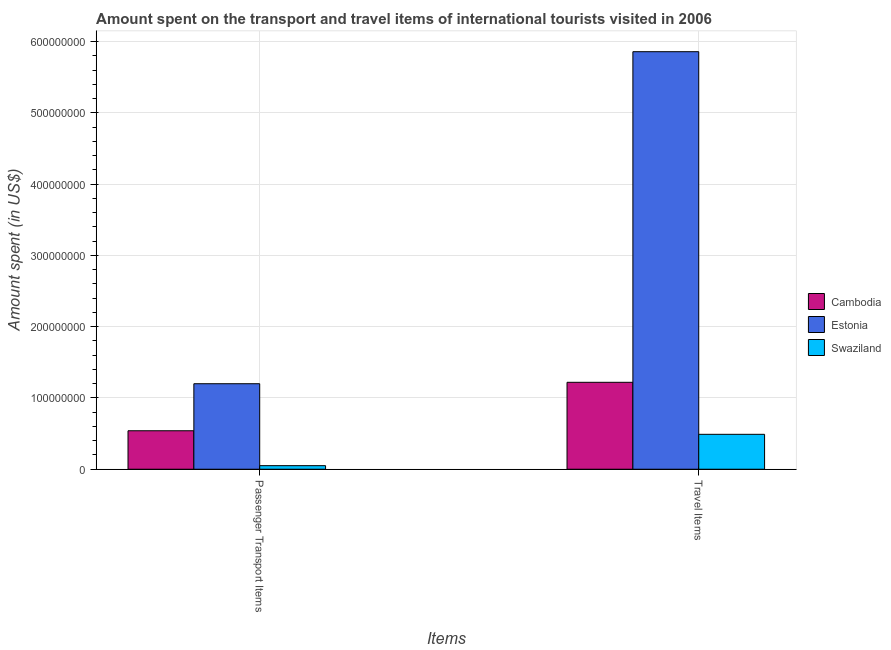Are the number of bars per tick equal to the number of legend labels?
Ensure brevity in your answer.  Yes. How many bars are there on the 2nd tick from the left?
Make the answer very short. 3. What is the label of the 1st group of bars from the left?
Your answer should be compact. Passenger Transport Items. What is the amount spent on passenger transport items in Estonia?
Keep it short and to the point. 1.20e+08. Across all countries, what is the maximum amount spent on passenger transport items?
Make the answer very short. 1.20e+08. Across all countries, what is the minimum amount spent in travel items?
Keep it short and to the point. 4.90e+07. In which country was the amount spent on passenger transport items maximum?
Your answer should be compact. Estonia. In which country was the amount spent on passenger transport items minimum?
Ensure brevity in your answer.  Swaziland. What is the total amount spent in travel items in the graph?
Your answer should be compact. 7.57e+08. What is the difference between the amount spent on passenger transport items in Estonia and that in Swaziland?
Make the answer very short. 1.15e+08. What is the difference between the amount spent in travel items in Swaziland and the amount spent on passenger transport items in Cambodia?
Your answer should be compact. -5.00e+06. What is the average amount spent in travel items per country?
Provide a short and direct response. 2.52e+08. What is the difference between the amount spent on passenger transport items and amount spent in travel items in Swaziland?
Provide a succinct answer. -4.40e+07. In how many countries, is the amount spent on passenger transport items greater than 380000000 US$?
Provide a succinct answer. 0. What is the ratio of the amount spent on passenger transport items in Swaziland to that in Cambodia?
Provide a succinct answer. 0.09. What does the 1st bar from the left in Passenger Transport Items represents?
Offer a very short reply. Cambodia. What does the 1st bar from the right in Travel Items represents?
Ensure brevity in your answer.  Swaziland. Does the graph contain grids?
Keep it short and to the point. Yes. How are the legend labels stacked?
Give a very brief answer. Vertical. What is the title of the graph?
Ensure brevity in your answer.  Amount spent on the transport and travel items of international tourists visited in 2006. Does "Botswana" appear as one of the legend labels in the graph?
Offer a very short reply. No. What is the label or title of the X-axis?
Give a very brief answer. Items. What is the label or title of the Y-axis?
Ensure brevity in your answer.  Amount spent (in US$). What is the Amount spent (in US$) of Cambodia in Passenger Transport Items?
Give a very brief answer. 5.40e+07. What is the Amount spent (in US$) in Estonia in Passenger Transport Items?
Provide a short and direct response. 1.20e+08. What is the Amount spent (in US$) of Swaziland in Passenger Transport Items?
Give a very brief answer. 5.00e+06. What is the Amount spent (in US$) in Cambodia in Travel Items?
Keep it short and to the point. 1.22e+08. What is the Amount spent (in US$) in Estonia in Travel Items?
Give a very brief answer. 5.86e+08. What is the Amount spent (in US$) in Swaziland in Travel Items?
Provide a succinct answer. 4.90e+07. Across all Items, what is the maximum Amount spent (in US$) of Cambodia?
Your answer should be compact. 1.22e+08. Across all Items, what is the maximum Amount spent (in US$) of Estonia?
Ensure brevity in your answer.  5.86e+08. Across all Items, what is the maximum Amount spent (in US$) of Swaziland?
Provide a succinct answer. 4.90e+07. Across all Items, what is the minimum Amount spent (in US$) in Cambodia?
Provide a succinct answer. 5.40e+07. Across all Items, what is the minimum Amount spent (in US$) in Estonia?
Your answer should be very brief. 1.20e+08. What is the total Amount spent (in US$) in Cambodia in the graph?
Give a very brief answer. 1.76e+08. What is the total Amount spent (in US$) in Estonia in the graph?
Your response must be concise. 7.06e+08. What is the total Amount spent (in US$) of Swaziland in the graph?
Your answer should be very brief. 5.40e+07. What is the difference between the Amount spent (in US$) in Cambodia in Passenger Transport Items and that in Travel Items?
Your response must be concise. -6.80e+07. What is the difference between the Amount spent (in US$) of Estonia in Passenger Transport Items and that in Travel Items?
Your answer should be compact. -4.66e+08. What is the difference between the Amount spent (in US$) of Swaziland in Passenger Transport Items and that in Travel Items?
Your answer should be very brief. -4.40e+07. What is the difference between the Amount spent (in US$) in Cambodia in Passenger Transport Items and the Amount spent (in US$) in Estonia in Travel Items?
Your answer should be compact. -5.32e+08. What is the difference between the Amount spent (in US$) of Estonia in Passenger Transport Items and the Amount spent (in US$) of Swaziland in Travel Items?
Provide a short and direct response. 7.10e+07. What is the average Amount spent (in US$) of Cambodia per Items?
Ensure brevity in your answer.  8.80e+07. What is the average Amount spent (in US$) in Estonia per Items?
Your answer should be compact. 3.53e+08. What is the average Amount spent (in US$) in Swaziland per Items?
Your response must be concise. 2.70e+07. What is the difference between the Amount spent (in US$) of Cambodia and Amount spent (in US$) of Estonia in Passenger Transport Items?
Provide a short and direct response. -6.60e+07. What is the difference between the Amount spent (in US$) of Cambodia and Amount spent (in US$) of Swaziland in Passenger Transport Items?
Provide a short and direct response. 4.90e+07. What is the difference between the Amount spent (in US$) in Estonia and Amount spent (in US$) in Swaziland in Passenger Transport Items?
Keep it short and to the point. 1.15e+08. What is the difference between the Amount spent (in US$) of Cambodia and Amount spent (in US$) of Estonia in Travel Items?
Keep it short and to the point. -4.64e+08. What is the difference between the Amount spent (in US$) in Cambodia and Amount spent (in US$) in Swaziland in Travel Items?
Keep it short and to the point. 7.30e+07. What is the difference between the Amount spent (in US$) of Estonia and Amount spent (in US$) of Swaziland in Travel Items?
Provide a short and direct response. 5.37e+08. What is the ratio of the Amount spent (in US$) in Cambodia in Passenger Transport Items to that in Travel Items?
Make the answer very short. 0.44. What is the ratio of the Amount spent (in US$) in Estonia in Passenger Transport Items to that in Travel Items?
Provide a short and direct response. 0.2. What is the ratio of the Amount spent (in US$) in Swaziland in Passenger Transport Items to that in Travel Items?
Offer a very short reply. 0.1. What is the difference between the highest and the second highest Amount spent (in US$) of Cambodia?
Offer a terse response. 6.80e+07. What is the difference between the highest and the second highest Amount spent (in US$) in Estonia?
Your response must be concise. 4.66e+08. What is the difference between the highest and the second highest Amount spent (in US$) in Swaziland?
Your answer should be compact. 4.40e+07. What is the difference between the highest and the lowest Amount spent (in US$) in Cambodia?
Offer a terse response. 6.80e+07. What is the difference between the highest and the lowest Amount spent (in US$) in Estonia?
Keep it short and to the point. 4.66e+08. What is the difference between the highest and the lowest Amount spent (in US$) in Swaziland?
Give a very brief answer. 4.40e+07. 